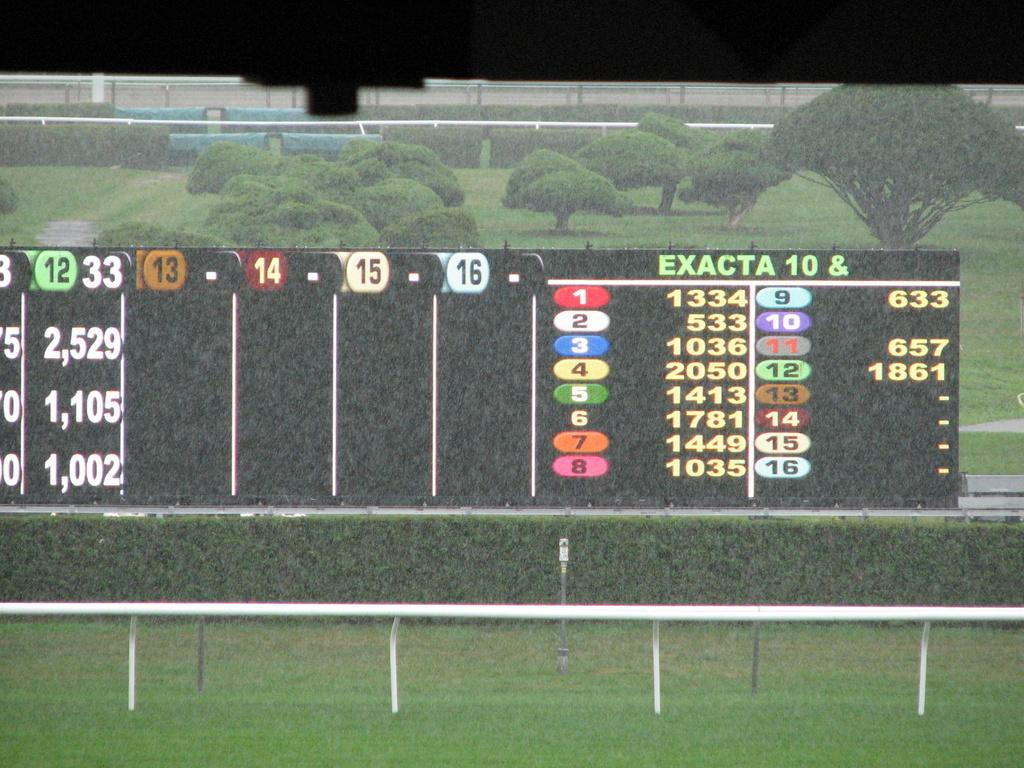<image>
Create a compact narrative representing the image presented. a scoreboard for a game with EXACTA 10 & with lists of numbers all over it. 